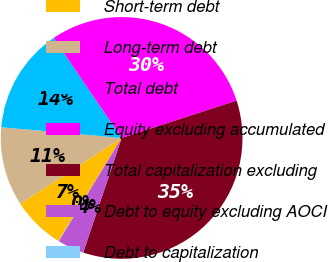Convert chart to OTSL. <chart><loc_0><loc_0><loc_500><loc_500><pie_chart><fcel>Short-term debt<fcel>Long-term debt<fcel>Total debt<fcel>Equity excluding accumulated<fcel>Total capitalization excluding<fcel>Debt to equity excluding AOCI<fcel>Debt to capitalization<nl><fcel>7.07%<fcel>10.58%<fcel>14.09%<fcel>29.51%<fcel>35.14%<fcel>3.56%<fcel>0.05%<nl></chart> 